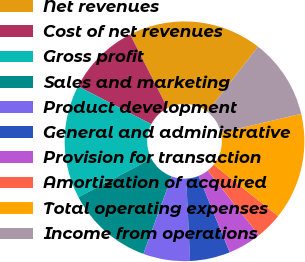<chart> <loc_0><loc_0><loc_500><loc_500><pie_chart><fcel>Net revenues<fcel>Cost of net revenues<fcel>Gross profit<fcel>Sales and marketing<fcel>Product development<fcel>General and administrative<fcel>Provision for transaction<fcel>Amortization of acquired<fcel>Total operating expenses<fcel>Income from operations<nl><fcel>18.01%<fcel>9.91%<fcel>15.31%<fcel>11.71%<fcel>6.31%<fcel>5.41%<fcel>4.51%<fcel>3.61%<fcel>14.41%<fcel>10.81%<nl></chart> 